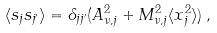Convert formula to latex. <formula><loc_0><loc_0><loc_500><loc_500>\langle s _ { j } s _ { j ^ { \prime } } \rangle = \delta _ { j j ^ { \prime } } ( A ^ { 2 } _ { \nu , j } + M ^ { 2 } _ { \nu , j } \langle x ^ { 2 } _ { j } \rangle ) \, ,</formula> 